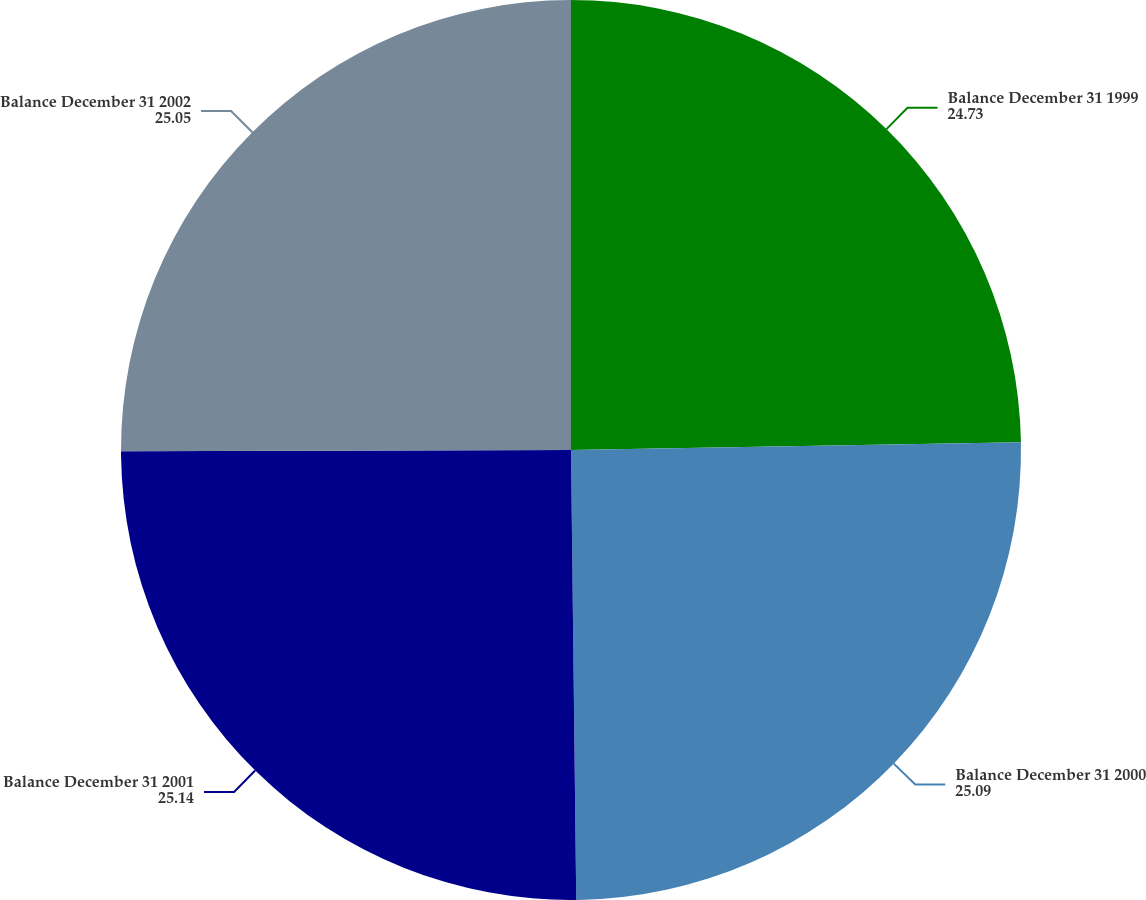Convert chart. <chart><loc_0><loc_0><loc_500><loc_500><pie_chart><fcel>Balance December 31 1999<fcel>Balance December 31 2000<fcel>Balance December 31 2001<fcel>Balance December 31 2002<nl><fcel>24.73%<fcel>25.09%<fcel>25.14%<fcel>25.05%<nl></chart> 